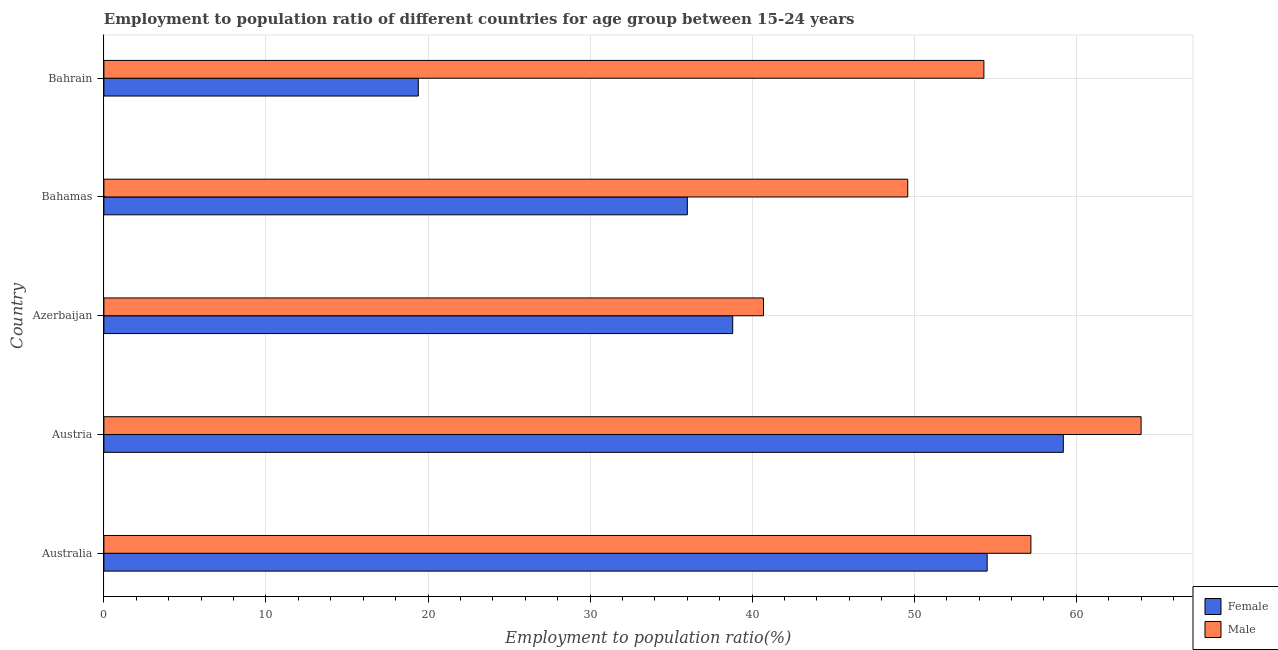How many different coloured bars are there?
Your response must be concise. 2. How many groups of bars are there?
Your response must be concise. 5. Are the number of bars per tick equal to the number of legend labels?
Provide a short and direct response. Yes. How many bars are there on the 5th tick from the bottom?
Offer a terse response. 2. What is the label of the 2nd group of bars from the top?
Provide a succinct answer. Bahamas. What is the employment to population ratio(female) in Australia?
Offer a very short reply. 54.5. Across all countries, what is the maximum employment to population ratio(female)?
Make the answer very short. 59.2. Across all countries, what is the minimum employment to population ratio(female)?
Provide a short and direct response. 19.4. In which country was the employment to population ratio(female) minimum?
Make the answer very short. Bahrain. What is the total employment to population ratio(female) in the graph?
Make the answer very short. 207.9. What is the difference between the employment to population ratio(female) in Azerbaijan and that in Bahrain?
Offer a very short reply. 19.4. What is the difference between the employment to population ratio(male) in Austria and the employment to population ratio(female) in Azerbaijan?
Your response must be concise. 25.2. What is the average employment to population ratio(male) per country?
Your answer should be compact. 53.16. What is the difference between the employment to population ratio(male) and employment to population ratio(female) in Azerbaijan?
Provide a succinct answer. 1.9. In how many countries, is the employment to population ratio(female) greater than 46 %?
Offer a very short reply. 2. What is the ratio of the employment to population ratio(female) in Australia to that in Bahamas?
Your answer should be very brief. 1.51. Is the employment to population ratio(male) in Bahamas less than that in Bahrain?
Make the answer very short. Yes. What is the difference between the highest and the lowest employment to population ratio(male)?
Keep it short and to the point. 23.3. What does the 2nd bar from the bottom in Bahamas represents?
Your answer should be very brief. Male. How many bars are there?
Make the answer very short. 10. Are all the bars in the graph horizontal?
Offer a terse response. Yes. What is the difference between two consecutive major ticks on the X-axis?
Provide a short and direct response. 10. Are the values on the major ticks of X-axis written in scientific E-notation?
Your answer should be compact. No. How many legend labels are there?
Offer a very short reply. 2. How are the legend labels stacked?
Offer a very short reply. Vertical. What is the title of the graph?
Make the answer very short. Employment to population ratio of different countries for age group between 15-24 years. Does "Fixed telephone" appear as one of the legend labels in the graph?
Provide a short and direct response. No. What is the Employment to population ratio(%) in Female in Australia?
Make the answer very short. 54.5. What is the Employment to population ratio(%) of Male in Australia?
Give a very brief answer. 57.2. What is the Employment to population ratio(%) of Female in Austria?
Keep it short and to the point. 59.2. What is the Employment to population ratio(%) of Male in Austria?
Make the answer very short. 64. What is the Employment to population ratio(%) in Female in Azerbaijan?
Make the answer very short. 38.8. What is the Employment to population ratio(%) in Male in Azerbaijan?
Your response must be concise. 40.7. What is the Employment to population ratio(%) in Male in Bahamas?
Make the answer very short. 49.6. What is the Employment to population ratio(%) in Female in Bahrain?
Keep it short and to the point. 19.4. What is the Employment to population ratio(%) in Male in Bahrain?
Offer a terse response. 54.3. Across all countries, what is the maximum Employment to population ratio(%) of Female?
Your answer should be compact. 59.2. Across all countries, what is the minimum Employment to population ratio(%) in Female?
Provide a succinct answer. 19.4. Across all countries, what is the minimum Employment to population ratio(%) of Male?
Your answer should be very brief. 40.7. What is the total Employment to population ratio(%) of Female in the graph?
Your answer should be very brief. 207.9. What is the total Employment to population ratio(%) of Male in the graph?
Offer a very short reply. 265.8. What is the difference between the Employment to population ratio(%) in Female in Australia and that in Austria?
Your answer should be very brief. -4.7. What is the difference between the Employment to population ratio(%) in Female in Australia and that in Bahamas?
Provide a succinct answer. 18.5. What is the difference between the Employment to population ratio(%) of Male in Australia and that in Bahamas?
Offer a terse response. 7.6. What is the difference between the Employment to population ratio(%) in Female in Australia and that in Bahrain?
Give a very brief answer. 35.1. What is the difference between the Employment to population ratio(%) in Male in Australia and that in Bahrain?
Give a very brief answer. 2.9. What is the difference between the Employment to population ratio(%) of Female in Austria and that in Azerbaijan?
Provide a short and direct response. 20.4. What is the difference between the Employment to population ratio(%) in Male in Austria and that in Azerbaijan?
Give a very brief answer. 23.3. What is the difference between the Employment to population ratio(%) of Female in Austria and that in Bahamas?
Provide a succinct answer. 23.2. What is the difference between the Employment to population ratio(%) in Female in Austria and that in Bahrain?
Ensure brevity in your answer.  39.8. What is the difference between the Employment to population ratio(%) in Female in Azerbaijan and that in Bahamas?
Your answer should be very brief. 2.8. What is the difference between the Employment to population ratio(%) of Male in Azerbaijan and that in Bahrain?
Provide a succinct answer. -13.6. What is the difference between the Employment to population ratio(%) in Female in Australia and the Employment to population ratio(%) in Male in Azerbaijan?
Offer a terse response. 13.8. What is the difference between the Employment to population ratio(%) in Female in Austria and the Employment to population ratio(%) in Male in Azerbaijan?
Provide a short and direct response. 18.5. What is the difference between the Employment to population ratio(%) in Female in Austria and the Employment to population ratio(%) in Male in Bahrain?
Offer a very short reply. 4.9. What is the difference between the Employment to population ratio(%) in Female in Azerbaijan and the Employment to population ratio(%) in Male in Bahrain?
Give a very brief answer. -15.5. What is the difference between the Employment to population ratio(%) of Female in Bahamas and the Employment to population ratio(%) of Male in Bahrain?
Your answer should be compact. -18.3. What is the average Employment to population ratio(%) of Female per country?
Your response must be concise. 41.58. What is the average Employment to population ratio(%) in Male per country?
Provide a succinct answer. 53.16. What is the difference between the Employment to population ratio(%) in Female and Employment to population ratio(%) in Male in Australia?
Keep it short and to the point. -2.7. What is the difference between the Employment to population ratio(%) in Female and Employment to population ratio(%) in Male in Austria?
Make the answer very short. -4.8. What is the difference between the Employment to population ratio(%) in Female and Employment to population ratio(%) in Male in Azerbaijan?
Provide a short and direct response. -1.9. What is the difference between the Employment to population ratio(%) of Female and Employment to population ratio(%) of Male in Bahamas?
Offer a very short reply. -13.6. What is the difference between the Employment to population ratio(%) in Female and Employment to population ratio(%) in Male in Bahrain?
Your answer should be very brief. -34.9. What is the ratio of the Employment to population ratio(%) in Female in Australia to that in Austria?
Offer a terse response. 0.92. What is the ratio of the Employment to population ratio(%) of Male in Australia to that in Austria?
Your answer should be compact. 0.89. What is the ratio of the Employment to population ratio(%) in Female in Australia to that in Azerbaijan?
Your answer should be compact. 1.4. What is the ratio of the Employment to population ratio(%) of Male in Australia to that in Azerbaijan?
Offer a terse response. 1.41. What is the ratio of the Employment to population ratio(%) in Female in Australia to that in Bahamas?
Ensure brevity in your answer.  1.51. What is the ratio of the Employment to population ratio(%) in Male in Australia to that in Bahamas?
Offer a terse response. 1.15. What is the ratio of the Employment to population ratio(%) of Female in Australia to that in Bahrain?
Provide a short and direct response. 2.81. What is the ratio of the Employment to population ratio(%) of Male in Australia to that in Bahrain?
Ensure brevity in your answer.  1.05. What is the ratio of the Employment to population ratio(%) of Female in Austria to that in Azerbaijan?
Your answer should be compact. 1.53. What is the ratio of the Employment to population ratio(%) in Male in Austria to that in Azerbaijan?
Provide a short and direct response. 1.57. What is the ratio of the Employment to population ratio(%) in Female in Austria to that in Bahamas?
Provide a short and direct response. 1.64. What is the ratio of the Employment to population ratio(%) of Male in Austria to that in Bahamas?
Offer a very short reply. 1.29. What is the ratio of the Employment to population ratio(%) in Female in Austria to that in Bahrain?
Provide a short and direct response. 3.05. What is the ratio of the Employment to population ratio(%) in Male in Austria to that in Bahrain?
Give a very brief answer. 1.18. What is the ratio of the Employment to population ratio(%) of Female in Azerbaijan to that in Bahamas?
Your response must be concise. 1.08. What is the ratio of the Employment to population ratio(%) of Male in Azerbaijan to that in Bahamas?
Give a very brief answer. 0.82. What is the ratio of the Employment to population ratio(%) in Female in Azerbaijan to that in Bahrain?
Your answer should be compact. 2. What is the ratio of the Employment to population ratio(%) of Male in Azerbaijan to that in Bahrain?
Ensure brevity in your answer.  0.75. What is the ratio of the Employment to population ratio(%) in Female in Bahamas to that in Bahrain?
Offer a very short reply. 1.86. What is the ratio of the Employment to population ratio(%) in Male in Bahamas to that in Bahrain?
Give a very brief answer. 0.91. What is the difference between the highest and the lowest Employment to population ratio(%) in Female?
Offer a terse response. 39.8. What is the difference between the highest and the lowest Employment to population ratio(%) of Male?
Ensure brevity in your answer.  23.3. 